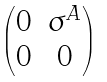<formula> <loc_0><loc_0><loc_500><loc_500>\begin{pmatrix} 0 & \sigma ^ { A } \\ 0 & 0 \end{pmatrix}</formula> 